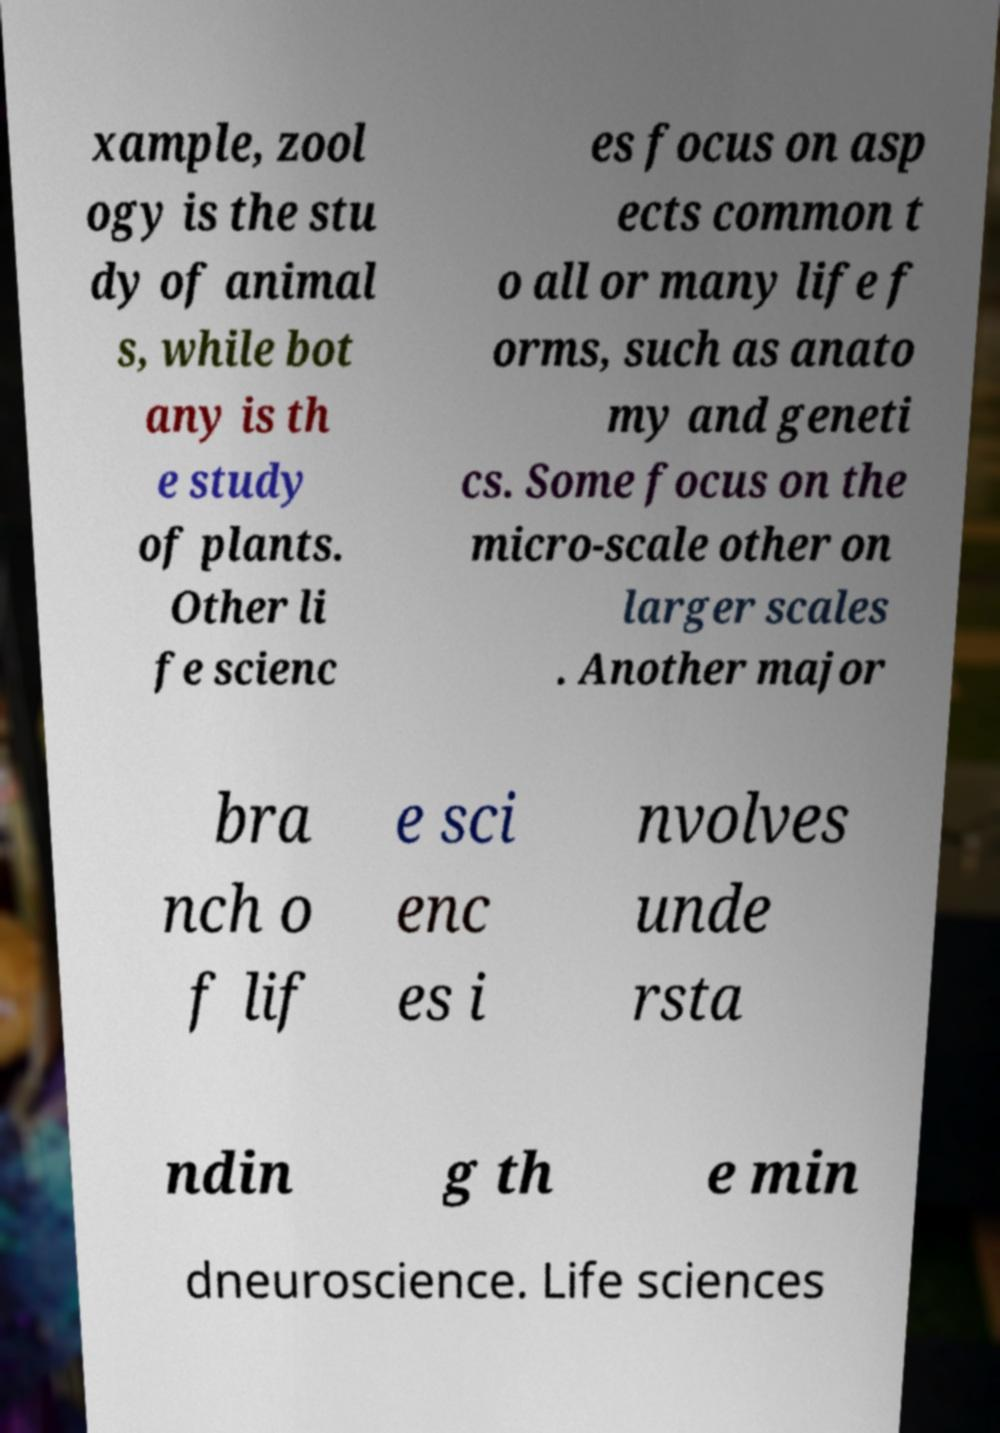For documentation purposes, I need the text within this image transcribed. Could you provide that? xample, zool ogy is the stu dy of animal s, while bot any is th e study of plants. Other li fe scienc es focus on asp ects common t o all or many life f orms, such as anato my and geneti cs. Some focus on the micro-scale other on larger scales . Another major bra nch o f lif e sci enc es i nvolves unde rsta ndin g th e min dneuroscience. Life sciences 